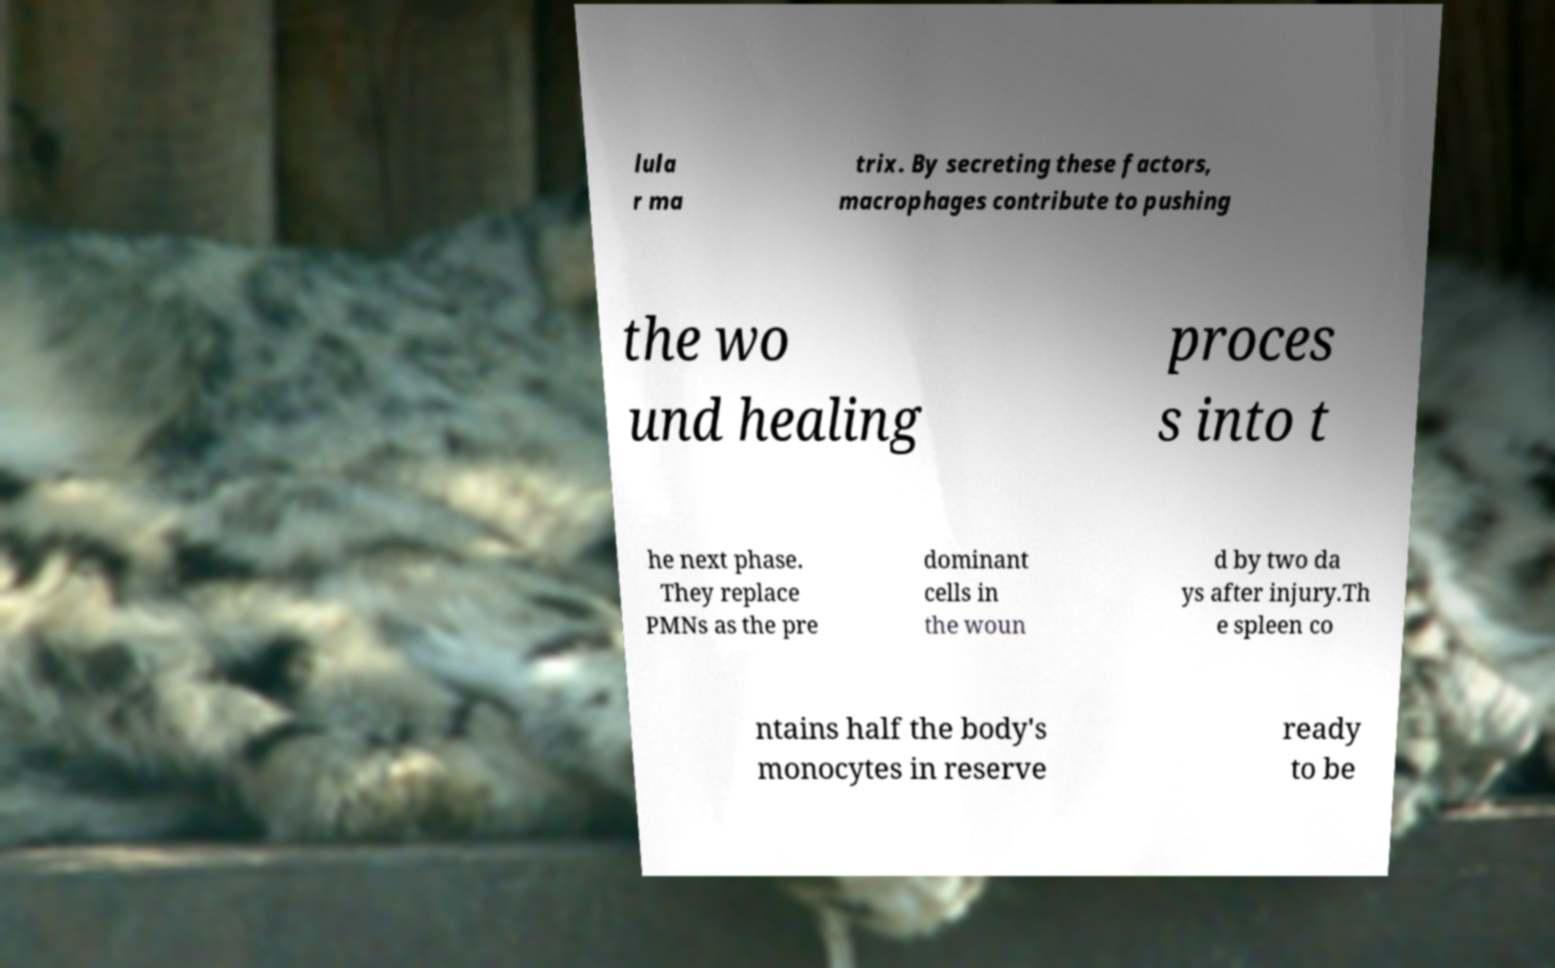There's text embedded in this image that I need extracted. Can you transcribe it verbatim? lula r ma trix. By secreting these factors, macrophages contribute to pushing the wo und healing proces s into t he next phase. They replace PMNs as the pre dominant cells in the woun d by two da ys after injury.Th e spleen co ntains half the body's monocytes in reserve ready to be 